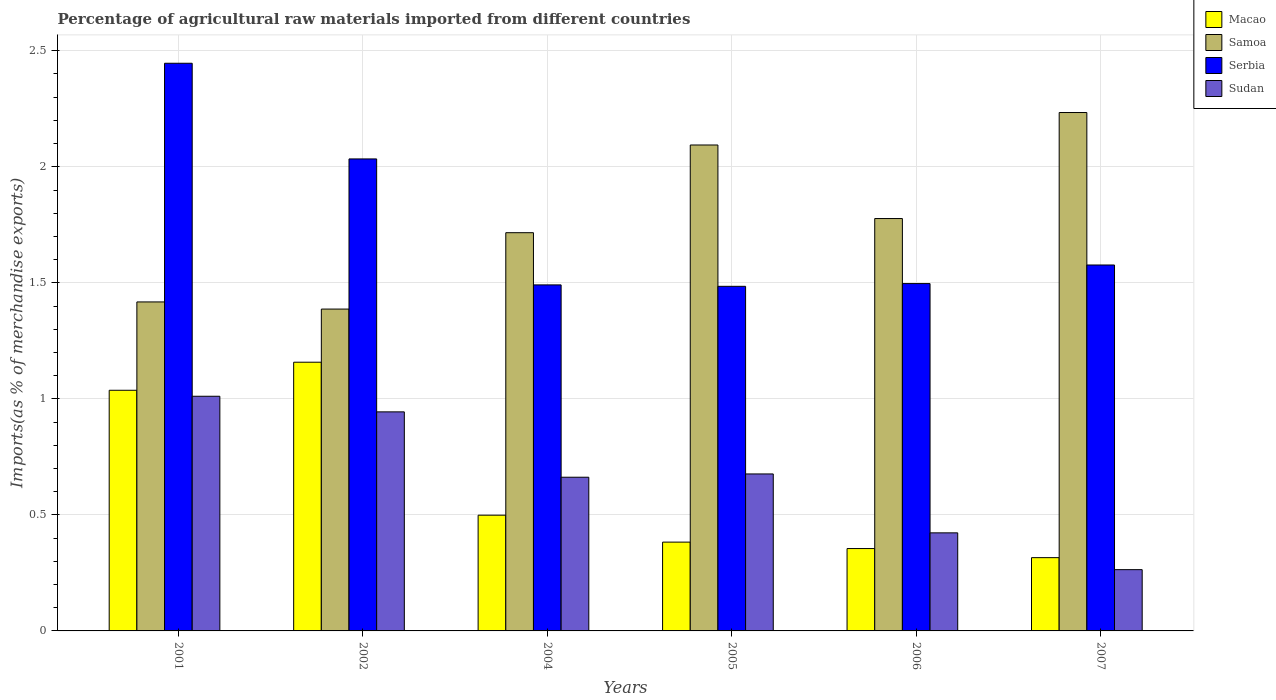How many different coloured bars are there?
Offer a very short reply. 4. Are the number of bars on each tick of the X-axis equal?
Provide a short and direct response. Yes. What is the label of the 6th group of bars from the left?
Provide a succinct answer. 2007. What is the percentage of imports to different countries in Macao in 2004?
Keep it short and to the point. 0.5. Across all years, what is the maximum percentage of imports to different countries in Sudan?
Your response must be concise. 1.01. Across all years, what is the minimum percentage of imports to different countries in Sudan?
Make the answer very short. 0.26. In which year was the percentage of imports to different countries in Serbia maximum?
Your answer should be very brief. 2001. What is the total percentage of imports to different countries in Samoa in the graph?
Offer a terse response. 10.63. What is the difference between the percentage of imports to different countries in Macao in 2004 and that in 2005?
Your answer should be compact. 0.12. What is the difference between the percentage of imports to different countries in Samoa in 2001 and the percentage of imports to different countries in Sudan in 2004?
Offer a very short reply. 0.76. What is the average percentage of imports to different countries in Macao per year?
Your response must be concise. 0.62. In the year 2005, what is the difference between the percentage of imports to different countries in Sudan and percentage of imports to different countries in Samoa?
Your response must be concise. -1.42. In how many years, is the percentage of imports to different countries in Serbia greater than 1.6 %?
Your response must be concise. 2. What is the ratio of the percentage of imports to different countries in Macao in 2006 to that in 2007?
Your answer should be very brief. 1.12. What is the difference between the highest and the second highest percentage of imports to different countries in Sudan?
Offer a terse response. 0.07. What is the difference between the highest and the lowest percentage of imports to different countries in Sudan?
Provide a short and direct response. 0.75. In how many years, is the percentage of imports to different countries in Macao greater than the average percentage of imports to different countries in Macao taken over all years?
Ensure brevity in your answer.  2. Is the sum of the percentage of imports to different countries in Samoa in 2004 and 2005 greater than the maximum percentage of imports to different countries in Serbia across all years?
Provide a succinct answer. Yes. What does the 3rd bar from the left in 2001 represents?
Keep it short and to the point. Serbia. What does the 4th bar from the right in 2002 represents?
Make the answer very short. Macao. How many bars are there?
Provide a succinct answer. 24. What is the difference between two consecutive major ticks on the Y-axis?
Provide a short and direct response. 0.5. Are the values on the major ticks of Y-axis written in scientific E-notation?
Give a very brief answer. No. What is the title of the graph?
Your response must be concise. Percentage of agricultural raw materials imported from different countries. Does "Rwanda" appear as one of the legend labels in the graph?
Your answer should be compact. No. What is the label or title of the X-axis?
Offer a very short reply. Years. What is the label or title of the Y-axis?
Offer a terse response. Imports(as % of merchandise exports). What is the Imports(as % of merchandise exports) of Macao in 2001?
Your answer should be very brief. 1.04. What is the Imports(as % of merchandise exports) of Samoa in 2001?
Provide a short and direct response. 1.42. What is the Imports(as % of merchandise exports) of Serbia in 2001?
Give a very brief answer. 2.45. What is the Imports(as % of merchandise exports) of Sudan in 2001?
Ensure brevity in your answer.  1.01. What is the Imports(as % of merchandise exports) in Macao in 2002?
Your answer should be compact. 1.16. What is the Imports(as % of merchandise exports) in Samoa in 2002?
Give a very brief answer. 1.39. What is the Imports(as % of merchandise exports) of Serbia in 2002?
Provide a short and direct response. 2.03. What is the Imports(as % of merchandise exports) in Sudan in 2002?
Your response must be concise. 0.94. What is the Imports(as % of merchandise exports) in Macao in 2004?
Offer a terse response. 0.5. What is the Imports(as % of merchandise exports) in Samoa in 2004?
Provide a short and direct response. 1.72. What is the Imports(as % of merchandise exports) in Serbia in 2004?
Your answer should be very brief. 1.49. What is the Imports(as % of merchandise exports) in Sudan in 2004?
Give a very brief answer. 0.66. What is the Imports(as % of merchandise exports) of Macao in 2005?
Your answer should be compact. 0.38. What is the Imports(as % of merchandise exports) of Samoa in 2005?
Your response must be concise. 2.09. What is the Imports(as % of merchandise exports) in Serbia in 2005?
Your response must be concise. 1.48. What is the Imports(as % of merchandise exports) of Sudan in 2005?
Provide a succinct answer. 0.68. What is the Imports(as % of merchandise exports) in Macao in 2006?
Your response must be concise. 0.35. What is the Imports(as % of merchandise exports) of Samoa in 2006?
Your answer should be very brief. 1.78. What is the Imports(as % of merchandise exports) in Serbia in 2006?
Keep it short and to the point. 1.5. What is the Imports(as % of merchandise exports) of Sudan in 2006?
Offer a very short reply. 0.42. What is the Imports(as % of merchandise exports) of Macao in 2007?
Provide a short and direct response. 0.32. What is the Imports(as % of merchandise exports) of Samoa in 2007?
Provide a short and direct response. 2.23. What is the Imports(as % of merchandise exports) of Serbia in 2007?
Your answer should be very brief. 1.58. What is the Imports(as % of merchandise exports) in Sudan in 2007?
Keep it short and to the point. 0.26. Across all years, what is the maximum Imports(as % of merchandise exports) of Macao?
Your response must be concise. 1.16. Across all years, what is the maximum Imports(as % of merchandise exports) of Samoa?
Offer a terse response. 2.23. Across all years, what is the maximum Imports(as % of merchandise exports) of Serbia?
Make the answer very short. 2.45. Across all years, what is the maximum Imports(as % of merchandise exports) of Sudan?
Make the answer very short. 1.01. Across all years, what is the minimum Imports(as % of merchandise exports) of Macao?
Your answer should be compact. 0.32. Across all years, what is the minimum Imports(as % of merchandise exports) in Samoa?
Your answer should be compact. 1.39. Across all years, what is the minimum Imports(as % of merchandise exports) of Serbia?
Ensure brevity in your answer.  1.48. Across all years, what is the minimum Imports(as % of merchandise exports) in Sudan?
Provide a short and direct response. 0.26. What is the total Imports(as % of merchandise exports) in Macao in the graph?
Make the answer very short. 3.75. What is the total Imports(as % of merchandise exports) in Samoa in the graph?
Provide a short and direct response. 10.63. What is the total Imports(as % of merchandise exports) of Serbia in the graph?
Ensure brevity in your answer.  10.53. What is the total Imports(as % of merchandise exports) of Sudan in the graph?
Give a very brief answer. 3.98. What is the difference between the Imports(as % of merchandise exports) in Macao in 2001 and that in 2002?
Provide a short and direct response. -0.12. What is the difference between the Imports(as % of merchandise exports) of Samoa in 2001 and that in 2002?
Provide a succinct answer. 0.03. What is the difference between the Imports(as % of merchandise exports) in Serbia in 2001 and that in 2002?
Ensure brevity in your answer.  0.41. What is the difference between the Imports(as % of merchandise exports) of Sudan in 2001 and that in 2002?
Provide a short and direct response. 0.07. What is the difference between the Imports(as % of merchandise exports) of Macao in 2001 and that in 2004?
Your answer should be very brief. 0.54. What is the difference between the Imports(as % of merchandise exports) in Samoa in 2001 and that in 2004?
Ensure brevity in your answer.  -0.3. What is the difference between the Imports(as % of merchandise exports) in Serbia in 2001 and that in 2004?
Provide a succinct answer. 0.96. What is the difference between the Imports(as % of merchandise exports) of Sudan in 2001 and that in 2004?
Ensure brevity in your answer.  0.35. What is the difference between the Imports(as % of merchandise exports) in Macao in 2001 and that in 2005?
Offer a terse response. 0.65. What is the difference between the Imports(as % of merchandise exports) of Samoa in 2001 and that in 2005?
Provide a short and direct response. -0.68. What is the difference between the Imports(as % of merchandise exports) of Serbia in 2001 and that in 2005?
Provide a succinct answer. 0.96. What is the difference between the Imports(as % of merchandise exports) of Sudan in 2001 and that in 2005?
Your response must be concise. 0.33. What is the difference between the Imports(as % of merchandise exports) in Macao in 2001 and that in 2006?
Your answer should be very brief. 0.68. What is the difference between the Imports(as % of merchandise exports) in Samoa in 2001 and that in 2006?
Your answer should be very brief. -0.36. What is the difference between the Imports(as % of merchandise exports) of Serbia in 2001 and that in 2006?
Offer a very short reply. 0.95. What is the difference between the Imports(as % of merchandise exports) of Sudan in 2001 and that in 2006?
Make the answer very short. 0.59. What is the difference between the Imports(as % of merchandise exports) in Macao in 2001 and that in 2007?
Keep it short and to the point. 0.72. What is the difference between the Imports(as % of merchandise exports) in Samoa in 2001 and that in 2007?
Provide a succinct answer. -0.82. What is the difference between the Imports(as % of merchandise exports) of Serbia in 2001 and that in 2007?
Provide a short and direct response. 0.87. What is the difference between the Imports(as % of merchandise exports) of Sudan in 2001 and that in 2007?
Your answer should be very brief. 0.75. What is the difference between the Imports(as % of merchandise exports) of Macao in 2002 and that in 2004?
Offer a terse response. 0.66. What is the difference between the Imports(as % of merchandise exports) of Samoa in 2002 and that in 2004?
Your answer should be compact. -0.33. What is the difference between the Imports(as % of merchandise exports) of Serbia in 2002 and that in 2004?
Provide a short and direct response. 0.54. What is the difference between the Imports(as % of merchandise exports) in Sudan in 2002 and that in 2004?
Offer a very short reply. 0.28. What is the difference between the Imports(as % of merchandise exports) in Macao in 2002 and that in 2005?
Ensure brevity in your answer.  0.78. What is the difference between the Imports(as % of merchandise exports) of Samoa in 2002 and that in 2005?
Make the answer very short. -0.71. What is the difference between the Imports(as % of merchandise exports) in Serbia in 2002 and that in 2005?
Keep it short and to the point. 0.55. What is the difference between the Imports(as % of merchandise exports) of Sudan in 2002 and that in 2005?
Your answer should be compact. 0.27. What is the difference between the Imports(as % of merchandise exports) in Macao in 2002 and that in 2006?
Give a very brief answer. 0.8. What is the difference between the Imports(as % of merchandise exports) in Samoa in 2002 and that in 2006?
Your answer should be very brief. -0.39. What is the difference between the Imports(as % of merchandise exports) of Serbia in 2002 and that in 2006?
Give a very brief answer. 0.54. What is the difference between the Imports(as % of merchandise exports) in Sudan in 2002 and that in 2006?
Offer a terse response. 0.52. What is the difference between the Imports(as % of merchandise exports) in Macao in 2002 and that in 2007?
Your response must be concise. 0.84. What is the difference between the Imports(as % of merchandise exports) of Samoa in 2002 and that in 2007?
Offer a very short reply. -0.85. What is the difference between the Imports(as % of merchandise exports) in Serbia in 2002 and that in 2007?
Your response must be concise. 0.46. What is the difference between the Imports(as % of merchandise exports) in Sudan in 2002 and that in 2007?
Make the answer very short. 0.68. What is the difference between the Imports(as % of merchandise exports) of Macao in 2004 and that in 2005?
Ensure brevity in your answer.  0.12. What is the difference between the Imports(as % of merchandise exports) in Samoa in 2004 and that in 2005?
Offer a very short reply. -0.38. What is the difference between the Imports(as % of merchandise exports) of Serbia in 2004 and that in 2005?
Your response must be concise. 0.01. What is the difference between the Imports(as % of merchandise exports) in Sudan in 2004 and that in 2005?
Provide a short and direct response. -0.01. What is the difference between the Imports(as % of merchandise exports) of Macao in 2004 and that in 2006?
Keep it short and to the point. 0.14. What is the difference between the Imports(as % of merchandise exports) of Samoa in 2004 and that in 2006?
Offer a terse response. -0.06. What is the difference between the Imports(as % of merchandise exports) in Serbia in 2004 and that in 2006?
Offer a very short reply. -0.01. What is the difference between the Imports(as % of merchandise exports) in Sudan in 2004 and that in 2006?
Offer a terse response. 0.24. What is the difference between the Imports(as % of merchandise exports) of Macao in 2004 and that in 2007?
Provide a succinct answer. 0.18. What is the difference between the Imports(as % of merchandise exports) in Samoa in 2004 and that in 2007?
Keep it short and to the point. -0.52. What is the difference between the Imports(as % of merchandise exports) in Serbia in 2004 and that in 2007?
Give a very brief answer. -0.09. What is the difference between the Imports(as % of merchandise exports) in Sudan in 2004 and that in 2007?
Your answer should be very brief. 0.4. What is the difference between the Imports(as % of merchandise exports) of Macao in 2005 and that in 2006?
Your answer should be compact. 0.03. What is the difference between the Imports(as % of merchandise exports) in Samoa in 2005 and that in 2006?
Give a very brief answer. 0.32. What is the difference between the Imports(as % of merchandise exports) in Serbia in 2005 and that in 2006?
Make the answer very short. -0.01. What is the difference between the Imports(as % of merchandise exports) of Sudan in 2005 and that in 2006?
Give a very brief answer. 0.25. What is the difference between the Imports(as % of merchandise exports) in Macao in 2005 and that in 2007?
Give a very brief answer. 0.07. What is the difference between the Imports(as % of merchandise exports) in Samoa in 2005 and that in 2007?
Your response must be concise. -0.14. What is the difference between the Imports(as % of merchandise exports) in Serbia in 2005 and that in 2007?
Give a very brief answer. -0.09. What is the difference between the Imports(as % of merchandise exports) in Sudan in 2005 and that in 2007?
Keep it short and to the point. 0.41. What is the difference between the Imports(as % of merchandise exports) in Macao in 2006 and that in 2007?
Give a very brief answer. 0.04. What is the difference between the Imports(as % of merchandise exports) in Samoa in 2006 and that in 2007?
Ensure brevity in your answer.  -0.46. What is the difference between the Imports(as % of merchandise exports) in Serbia in 2006 and that in 2007?
Your answer should be very brief. -0.08. What is the difference between the Imports(as % of merchandise exports) in Sudan in 2006 and that in 2007?
Your answer should be compact. 0.16. What is the difference between the Imports(as % of merchandise exports) in Macao in 2001 and the Imports(as % of merchandise exports) in Samoa in 2002?
Make the answer very short. -0.35. What is the difference between the Imports(as % of merchandise exports) of Macao in 2001 and the Imports(as % of merchandise exports) of Serbia in 2002?
Provide a succinct answer. -1. What is the difference between the Imports(as % of merchandise exports) of Macao in 2001 and the Imports(as % of merchandise exports) of Sudan in 2002?
Provide a succinct answer. 0.09. What is the difference between the Imports(as % of merchandise exports) of Samoa in 2001 and the Imports(as % of merchandise exports) of Serbia in 2002?
Provide a succinct answer. -0.62. What is the difference between the Imports(as % of merchandise exports) in Samoa in 2001 and the Imports(as % of merchandise exports) in Sudan in 2002?
Your answer should be compact. 0.47. What is the difference between the Imports(as % of merchandise exports) of Serbia in 2001 and the Imports(as % of merchandise exports) of Sudan in 2002?
Offer a very short reply. 1.5. What is the difference between the Imports(as % of merchandise exports) in Macao in 2001 and the Imports(as % of merchandise exports) in Samoa in 2004?
Give a very brief answer. -0.68. What is the difference between the Imports(as % of merchandise exports) of Macao in 2001 and the Imports(as % of merchandise exports) of Serbia in 2004?
Your answer should be compact. -0.45. What is the difference between the Imports(as % of merchandise exports) of Macao in 2001 and the Imports(as % of merchandise exports) of Sudan in 2004?
Your response must be concise. 0.37. What is the difference between the Imports(as % of merchandise exports) of Samoa in 2001 and the Imports(as % of merchandise exports) of Serbia in 2004?
Your answer should be compact. -0.07. What is the difference between the Imports(as % of merchandise exports) of Samoa in 2001 and the Imports(as % of merchandise exports) of Sudan in 2004?
Ensure brevity in your answer.  0.76. What is the difference between the Imports(as % of merchandise exports) in Serbia in 2001 and the Imports(as % of merchandise exports) in Sudan in 2004?
Your response must be concise. 1.78. What is the difference between the Imports(as % of merchandise exports) of Macao in 2001 and the Imports(as % of merchandise exports) of Samoa in 2005?
Offer a terse response. -1.06. What is the difference between the Imports(as % of merchandise exports) in Macao in 2001 and the Imports(as % of merchandise exports) in Serbia in 2005?
Make the answer very short. -0.45. What is the difference between the Imports(as % of merchandise exports) in Macao in 2001 and the Imports(as % of merchandise exports) in Sudan in 2005?
Offer a terse response. 0.36. What is the difference between the Imports(as % of merchandise exports) in Samoa in 2001 and the Imports(as % of merchandise exports) in Serbia in 2005?
Make the answer very short. -0.07. What is the difference between the Imports(as % of merchandise exports) of Samoa in 2001 and the Imports(as % of merchandise exports) of Sudan in 2005?
Your answer should be very brief. 0.74. What is the difference between the Imports(as % of merchandise exports) of Serbia in 2001 and the Imports(as % of merchandise exports) of Sudan in 2005?
Your answer should be compact. 1.77. What is the difference between the Imports(as % of merchandise exports) in Macao in 2001 and the Imports(as % of merchandise exports) in Samoa in 2006?
Give a very brief answer. -0.74. What is the difference between the Imports(as % of merchandise exports) in Macao in 2001 and the Imports(as % of merchandise exports) in Serbia in 2006?
Offer a very short reply. -0.46. What is the difference between the Imports(as % of merchandise exports) in Macao in 2001 and the Imports(as % of merchandise exports) in Sudan in 2006?
Your answer should be compact. 0.61. What is the difference between the Imports(as % of merchandise exports) in Samoa in 2001 and the Imports(as % of merchandise exports) in Serbia in 2006?
Your response must be concise. -0.08. What is the difference between the Imports(as % of merchandise exports) in Samoa in 2001 and the Imports(as % of merchandise exports) in Sudan in 2006?
Your answer should be compact. 1. What is the difference between the Imports(as % of merchandise exports) in Serbia in 2001 and the Imports(as % of merchandise exports) in Sudan in 2006?
Your answer should be compact. 2.02. What is the difference between the Imports(as % of merchandise exports) in Macao in 2001 and the Imports(as % of merchandise exports) in Samoa in 2007?
Provide a succinct answer. -1.2. What is the difference between the Imports(as % of merchandise exports) in Macao in 2001 and the Imports(as % of merchandise exports) in Serbia in 2007?
Give a very brief answer. -0.54. What is the difference between the Imports(as % of merchandise exports) of Macao in 2001 and the Imports(as % of merchandise exports) of Sudan in 2007?
Offer a terse response. 0.77. What is the difference between the Imports(as % of merchandise exports) of Samoa in 2001 and the Imports(as % of merchandise exports) of Serbia in 2007?
Ensure brevity in your answer.  -0.16. What is the difference between the Imports(as % of merchandise exports) in Samoa in 2001 and the Imports(as % of merchandise exports) in Sudan in 2007?
Ensure brevity in your answer.  1.15. What is the difference between the Imports(as % of merchandise exports) in Serbia in 2001 and the Imports(as % of merchandise exports) in Sudan in 2007?
Offer a terse response. 2.18. What is the difference between the Imports(as % of merchandise exports) in Macao in 2002 and the Imports(as % of merchandise exports) in Samoa in 2004?
Provide a short and direct response. -0.56. What is the difference between the Imports(as % of merchandise exports) in Macao in 2002 and the Imports(as % of merchandise exports) in Serbia in 2004?
Provide a succinct answer. -0.33. What is the difference between the Imports(as % of merchandise exports) of Macao in 2002 and the Imports(as % of merchandise exports) of Sudan in 2004?
Offer a terse response. 0.5. What is the difference between the Imports(as % of merchandise exports) in Samoa in 2002 and the Imports(as % of merchandise exports) in Serbia in 2004?
Your response must be concise. -0.1. What is the difference between the Imports(as % of merchandise exports) in Samoa in 2002 and the Imports(as % of merchandise exports) in Sudan in 2004?
Your response must be concise. 0.72. What is the difference between the Imports(as % of merchandise exports) of Serbia in 2002 and the Imports(as % of merchandise exports) of Sudan in 2004?
Your response must be concise. 1.37. What is the difference between the Imports(as % of merchandise exports) in Macao in 2002 and the Imports(as % of merchandise exports) in Samoa in 2005?
Provide a short and direct response. -0.94. What is the difference between the Imports(as % of merchandise exports) in Macao in 2002 and the Imports(as % of merchandise exports) in Serbia in 2005?
Offer a terse response. -0.33. What is the difference between the Imports(as % of merchandise exports) in Macao in 2002 and the Imports(as % of merchandise exports) in Sudan in 2005?
Give a very brief answer. 0.48. What is the difference between the Imports(as % of merchandise exports) of Samoa in 2002 and the Imports(as % of merchandise exports) of Serbia in 2005?
Keep it short and to the point. -0.1. What is the difference between the Imports(as % of merchandise exports) in Samoa in 2002 and the Imports(as % of merchandise exports) in Sudan in 2005?
Your answer should be compact. 0.71. What is the difference between the Imports(as % of merchandise exports) of Serbia in 2002 and the Imports(as % of merchandise exports) of Sudan in 2005?
Offer a very short reply. 1.36. What is the difference between the Imports(as % of merchandise exports) in Macao in 2002 and the Imports(as % of merchandise exports) in Samoa in 2006?
Offer a terse response. -0.62. What is the difference between the Imports(as % of merchandise exports) in Macao in 2002 and the Imports(as % of merchandise exports) in Serbia in 2006?
Your answer should be compact. -0.34. What is the difference between the Imports(as % of merchandise exports) of Macao in 2002 and the Imports(as % of merchandise exports) of Sudan in 2006?
Offer a very short reply. 0.74. What is the difference between the Imports(as % of merchandise exports) in Samoa in 2002 and the Imports(as % of merchandise exports) in Serbia in 2006?
Keep it short and to the point. -0.11. What is the difference between the Imports(as % of merchandise exports) in Samoa in 2002 and the Imports(as % of merchandise exports) in Sudan in 2006?
Offer a very short reply. 0.96. What is the difference between the Imports(as % of merchandise exports) in Serbia in 2002 and the Imports(as % of merchandise exports) in Sudan in 2006?
Your response must be concise. 1.61. What is the difference between the Imports(as % of merchandise exports) of Macao in 2002 and the Imports(as % of merchandise exports) of Samoa in 2007?
Give a very brief answer. -1.08. What is the difference between the Imports(as % of merchandise exports) of Macao in 2002 and the Imports(as % of merchandise exports) of Serbia in 2007?
Give a very brief answer. -0.42. What is the difference between the Imports(as % of merchandise exports) of Macao in 2002 and the Imports(as % of merchandise exports) of Sudan in 2007?
Make the answer very short. 0.89. What is the difference between the Imports(as % of merchandise exports) in Samoa in 2002 and the Imports(as % of merchandise exports) in Serbia in 2007?
Your response must be concise. -0.19. What is the difference between the Imports(as % of merchandise exports) of Samoa in 2002 and the Imports(as % of merchandise exports) of Sudan in 2007?
Ensure brevity in your answer.  1.12. What is the difference between the Imports(as % of merchandise exports) of Serbia in 2002 and the Imports(as % of merchandise exports) of Sudan in 2007?
Your answer should be very brief. 1.77. What is the difference between the Imports(as % of merchandise exports) in Macao in 2004 and the Imports(as % of merchandise exports) in Samoa in 2005?
Your answer should be very brief. -1.6. What is the difference between the Imports(as % of merchandise exports) in Macao in 2004 and the Imports(as % of merchandise exports) in Serbia in 2005?
Provide a succinct answer. -0.99. What is the difference between the Imports(as % of merchandise exports) in Macao in 2004 and the Imports(as % of merchandise exports) in Sudan in 2005?
Offer a terse response. -0.18. What is the difference between the Imports(as % of merchandise exports) in Samoa in 2004 and the Imports(as % of merchandise exports) in Serbia in 2005?
Your answer should be very brief. 0.23. What is the difference between the Imports(as % of merchandise exports) of Samoa in 2004 and the Imports(as % of merchandise exports) of Sudan in 2005?
Give a very brief answer. 1.04. What is the difference between the Imports(as % of merchandise exports) of Serbia in 2004 and the Imports(as % of merchandise exports) of Sudan in 2005?
Offer a terse response. 0.81. What is the difference between the Imports(as % of merchandise exports) of Macao in 2004 and the Imports(as % of merchandise exports) of Samoa in 2006?
Offer a terse response. -1.28. What is the difference between the Imports(as % of merchandise exports) in Macao in 2004 and the Imports(as % of merchandise exports) in Serbia in 2006?
Offer a terse response. -1. What is the difference between the Imports(as % of merchandise exports) in Macao in 2004 and the Imports(as % of merchandise exports) in Sudan in 2006?
Offer a very short reply. 0.08. What is the difference between the Imports(as % of merchandise exports) in Samoa in 2004 and the Imports(as % of merchandise exports) in Serbia in 2006?
Offer a very short reply. 0.22. What is the difference between the Imports(as % of merchandise exports) in Samoa in 2004 and the Imports(as % of merchandise exports) in Sudan in 2006?
Offer a terse response. 1.29. What is the difference between the Imports(as % of merchandise exports) in Serbia in 2004 and the Imports(as % of merchandise exports) in Sudan in 2006?
Keep it short and to the point. 1.07. What is the difference between the Imports(as % of merchandise exports) of Macao in 2004 and the Imports(as % of merchandise exports) of Samoa in 2007?
Give a very brief answer. -1.74. What is the difference between the Imports(as % of merchandise exports) of Macao in 2004 and the Imports(as % of merchandise exports) of Serbia in 2007?
Your answer should be compact. -1.08. What is the difference between the Imports(as % of merchandise exports) in Macao in 2004 and the Imports(as % of merchandise exports) in Sudan in 2007?
Offer a very short reply. 0.23. What is the difference between the Imports(as % of merchandise exports) in Samoa in 2004 and the Imports(as % of merchandise exports) in Serbia in 2007?
Your answer should be compact. 0.14. What is the difference between the Imports(as % of merchandise exports) of Samoa in 2004 and the Imports(as % of merchandise exports) of Sudan in 2007?
Make the answer very short. 1.45. What is the difference between the Imports(as % of merchandise exports) of Serbia in 2004 and the Imports(as % of merchandise exports) of Sudan in 2007?
Offer a very short reply. 1.23. What is the difference between the Imports(as % of merchandise exports) in Macao in 2005 and the Imports(as % of merchandise exports) in Samoa in 2006?
Your answer should be very brief. -1.39. What is the difference between the Imports(as % of merchandise exports) in Macao in 2005 and the Imports(as % of merchandise exports) in Serbia in 2006?
Provide a short and direct response. -1.11. What is the difference between the Imports(as % of merchandise exports) in Macao in 2005 and the Imports(as % of merchandise exports) in Sudan in 2006?
Offer a terse response. -0.04. What is the difference between the Imports(as % of merchandise exports) of Samoa in 2005 and the Imports(as % of merchandise exports) of Serbia in 2006?
Provide a short and direct response. 0.6. What is the difference between the Imports(as % of merchandise exports) in Samoa in 2005 and the Imports(as % of merchandise exports) in Sudan in 2006?
Offer a terse response. 1.67. What is the difference between the Imports(as % of merchandise exports) in Serbia in 2005 and the Imports(as % of merchandise exports) in Sudan in 2006?
Offer a terse response. 1.06. What is the difference between the Imports(as % of merchandise exports) of Macao in 2005 and the Imports(as % of merchandise exports) of Samoa in 2007?
Make the answer very short. -1.85. What is the difference between the Imports(as % of merchandise exports) of Macao in 2005 and the Imports(as % of merchandise exports) of Serbia in 2007?
Your response must be concise. -1.19. What is the difference between the Imports(as % of merchandise exports) in Macao in 2005 and the Imports(as % of merchandise exports) in Sudan in 2007?
Make the answer very short. 0.12. What is the difference between the Imports(as % of merchandise exports) of Samoa in 2005 and the Imports(as % of merchandise exports) of Serbia in 2007?
Your answer should be very brief. 0.52. What is the difference between the Imports(as % of merchandise exports) in Samoa in 2005 and the Imports(as % of merchandise exports) in Sudan in 2007?
Provide a short and direct response. 1.83. What is the difference between the Imports(as % of merchandise exports) of Serbia in 2005 and the Imports(as % of merchandise exports) of Sudan in 2007?
Your response must be concise. 1.22. What is the difference between the Imports(as % of merchandise exports) in Macao in 2006 and the Imports(as % of merchandise exports) in Samoa in 2007?
Your response must be concise. -1.88. What is the difference between the Imports(as % of merchandise exports) of Macao in 2006 and the Imports(as % of merchandise exports) of Serbia in 2007?
Your answer should be very brief. -1.22. What is the difference between the Imports(as % of merchandise exports) in Macao in 2006 and the Imports(as % of merchandise exports) in Sudan in 2007?
Your answer should be very brief. 0.09. What is the difference between the Imports(as % of merchandise exports) in Samoa in 2006 and the Imports(as % of merchandise exports) in Serbia in 2007?
Provide a succinct answer. 0.2. What is the difference between the Imports(as % of merchandise exports) of Samoa in 2006 and the Imports(as % of merchandise exports) of Sudan in 2007?
Your response must be concise. 1.51. What is the difference between the Imports(as % of merchandise exports) of Serbia in 2006 and the Imports(as % of merchandise exports) of Sudan in 2007?
Ensure brevity in your answer.  1.23. What is the average Imports(as % of merchandise exports) of Macao per year?
Your response must be concise. 0.62. What is the average Imports(as % of merchandise exports) in Samoa per year?
Your response must be concise. 1.77. What is the average Imports(as % of merchandise exports) of Serbia per year?
Your answer should be very brief. 1.75. What is the average Imports(as % of merchandise exports) of Sudan per year?
Keep it short and to the point. 0.66. In the year 2001, what is the difference between the Imports(as % of merchandise exports) of Macao and Imports(as % of merchandise exports) of Samoa?
Your answer should be compact. -0.38. In the year 2001, what is the difference between the Imports(as % of merchandise exports) in Macao and Imports(as % of merchandise exports) in Serbia?
Keep it short and to the point. -1.41. In the year 2001, what is the difference between the Imports(as % of merchandise exports) in Macao and Imports(as % of merchandise exports) in Sudan?
Offer a terse response. 0.03. In the year 2001, what is the difference between the Imports(as % of merchandise exports) of Samoa and Imports(as % of merchandise exports) of Serbia?
Your answer should be compact. -1.03. In the year 2001, what is the difference between the Imports(as % of merchandise exports) of Samoa and Imports(as % of merchandise exports) of Sudan?
Ensure brevity in your answer.  0.41. In the year 2001, what is the difference between the Imports(as % of merchandise exports) in Serbia and Imports(as % of merchandise exports) in Sudan?
Offer a terse response. 1.44. In the year 2002, what is the difference between the Imports(as % of merchandise exports) of Macao and Imports(as % of merchandise exports) of Samoa?
Provide a short and direct response. -0.23. In the year 2002, what is the difference between the Imports(as % of merchandise exports) in Macao and Imports(as % of merchandise exports) in Serbia?
Give a very brief answer. -0.88. In the year 2002, what is the difference between the Imports(as % of merchandise exports) of Macao and Imports(as % of merchandise exports) of Sudan?
Your response must be concise. 0.21. In the year 2002, what is the difference between the Imports(as % of merchandise exports) in Samoa and Imports(as % of merchandise exports) in Serbia?
Offer a very short reply. -0.65. In the year 2002, what is the difference between the Imports(as % of merchandise exports) in Samoa and Imports(as % of merchandise exports) in Sudan?
Your answer should be very brief. 0.44. In the year 2002, what is the difference between the Imports(as % of merchandise exports) in Serbia and Imports(as % of merchandise exports) in Sudan?
Provide a succinct answer. 1.09. In the year 2004, what is the difference between the Imports(as % of merchandise exports) of Macao and Imports(as % of merchandise exports) of Samoa?
Offer a very short reply. -1.22. In the year 2004, what is the difference between the Imports(as % of merchandise exports) in Macao and Imports(as % of merchandise exports) in Serbia?
Your answer should be very brief. -0.99. In the year 2004, what is the difference between the Imports(as % of merchandise exports) in Macao and Imports(as % of merchandise exports) in Sudan?
Keep it short and to the point. -0.16. In the year 2004, what is the difference between the Imports(as % of merchandise exports) in Samoa and Imports(as % of merchandise exports) in Serbia?
Give a very brief answer. 0.22. In the year 2004, what is the difference between the Imports(as % of merchandise exports) of Samoa and Imports(as % of merchandise exports) of Sudan?
Your answer should be compact. 1.05. In the year 2004, what is the difference between the Imports(as % of merchandise exports) in Serbia and Imports(as % of merchandise exports) in Sudan?
Offer a very short reply. 0.83. In the year 2005, what is the difference between the Imports(as % of merchandise exports) in Macao and Imports(as % of merchandise exports) in Samoa?
Your response must be concise. -1.71. In the year 2005, what is the difference between the Imports(as % of merchandise exports) in Macao and Imports(as % of merchandise exports) in Serbia?
Provide a short and direct response. -1.1. In the year 2005, what is the difference between the Imports(as % of merchandise exports) in Macao and Imports(as % of merchandise exports) in Sudan?
Your answer should be compact. -0.29. In the year 2005, what is the difference between the Imports(as % of merchandise exports) of Samoa and Imports(as % of merchandise exports) of Serbia?
Your response must be concise. 0.61. In the year 2005, what is the difference between the Imports(as % of merchandise exports) in Samoa and Imports(as % of merchandise exports) in Sudan?
Ensure brevity in your answer.  1.42. In the year 2005, what is the difference between the Imports(as % of merchandise exports) in Serbia and Imports(as % of merchandise exports) in Sudan?
Your response must be concise. 0.81. In the year 2006, what is the difference between the Imports(as % of merchandise exports) of Macao and Imports(as % of merchandise exports) of Samoa?
Provide a short and direct response. -1.42. In the year 2006, what is the difference between the Imports(as % of merchandise exports) in Macao and Imports(as % of merchandise exports) in Serbia?
Provide a succinct answer. -1.14. In the year 2006, what is the difference between the Imports(as % of merchandise exports) of Macao and Imports(as % of merchandise exports) of Sudan?
Your answer should be very brief. -0.07. In the year 2006, what is the difference between the Imports(as % of merchandise exports) in Samoa and Imports(as % of merchandise exports) in Serbia?
Keep it short and to the point. 0.28. In the year 2006, what is the difference between the Imports(as % of merchandise exports) in Samoa and Imports(as % of merchandise exports) in Sudan?
Offer a very short reply. 1.35. In the year 2006, what is the difference between the Imports(as % of merchandise exports) in Serbia and Imports(as % of merchandise exports) in Sudan?
Make the answer very short. 1.07. In the year 2007, what is the difference between the Imports(as % of merchandise exports) in Macao and Imports(as % of merchandise exports) in Samoa?
Ensure brevity in your answer.  -1.92. In the year 2007, what is the difference between the Imports(as % of merchandise exports) of Macao and Imports(as % of merchandise exports) of Serbia?
Ensure brevity in your answer.  -1.26. In the year 2007, what is the difference between the Imports(as % of merchandise exports) of Macao and Imports(as % of merchandise exports) of Sudan?
Your answer should be very brief. 0.05. In the year 2007, what is the difference between the Imports(as % of merchandise exports) of Samoa and Imports(as % of merchandise exports) of Serbia?
Provide a succinct answer. 0.66. In the year 2007, what is the difference between the Imports(as % of merchandise exports) in Samoa and Imports(as % of merchandise exports) in Sudan?
Your answer should be very brief. 1.97. In the year 2007, what is the difference between the Imports(as % of merchandise exports) in Serbia and Imports(as % of merchandise exports) in Sudan?
Provide a short and direct response. 1.31. What is the ratio of the Imports(as % of merchandise exports) in Macao in 2001 to that in 2002?
Your answer should be compact. 0.9. What is the ratio of the Imports(as % of merchandise exports) of Samoa in 2001 to that in 2002?
Your response must be concise. 1.02. What is the ratio of the Imports(as % of merchandise exports) in Serbia in 2001 to that in 2002?
Ensure brevity in your answer.  1.2. What is the ratio of the Imports(as % of merchandise exports) in Sudan in 2001 to that in 2002?
Give a very brief answer. 1.07. What is the ratio of the Imports(as % of merchandise exports) of Macao in 2001 to that in 2004?
Your answer should be compact. 2.08. What is the ratio of the Imports(as % of merchandise exports) of Samoa in 2001 to that in 2004?
Your answer should be compact. 0.83. What is the ratio of the Imports(as % of merchandise exports) of Serbia in 2001 to that in 2004?
Keep it short and to the point. 1.64. What is the ratio of the Imports(as % of merchandise exports) in Sudan in 2001 to that in 2004?
Offer a terse response. 1.53. What is the ratio of the Imports(as % of merchandise exports) in Macao in 2001 to that in 2005?
Make the answer very short. 2.71. What is the ratio of the Imports(as % of merchandise exports) in Samoa in 2001 to that in 2005?
Your answer should be very brief. 0.68. What is the ratio of the Imports(as % of merchandise exports) of Serbia in 2001 to that in 2005?
Offer a very short reply. 1.65. What is the ratio of the Imports(as % of merchandise exports) of Sudan in 2001 to that in 2005?
Provide a succinct answer. 1.49. What is the ratio of the Imports(as % of merchandise exports) of Macao in 2001 to that in 2006?
Ensure brevity in your answer.  2.92. What is the ratio of the Imports(as % of merchandise exports) in Samoa in 2001 to that in 2006?
Your response must be concise. 0.8. What is the ratio of the Imports(as % of merchandise exports) of Serbia in 2001 to that in 2006?
Offer a terse response. 1.63. What is the ratio of the Imports(as % of merchandise exports) of Sudan in 2001 to that in 2006?
Give a very brief answer. 2.39. What is the ratio of the Imports(as % of merchandise exports) in Macao in 2001 to that in 2007?
Your answer should be compact. 3.28. What is the ratio of the Imports(as % of merchandise exports) in Samoa in 2001 to that in 2007?
Offer a terse response. 0.63. What is the ratio of the Imports(as % of merchandise exports) in Serbia in 2001 to that in 2007?
Offer a terse response. 1.55. What is the ratio of the Imports(as % of merchandise exports) in Sudan in 2001 to that in 2007?
Your response must be concise. 3.83. What is the ratio of the Imports(as % of merchandise exports) in Macao in 2002 to that in 2004?
Provide a succinct answer. 2.32. What is the ratio of the Imports(as % of merchandise exports) of Samoa in 2002 to that in 2004?
Provide a short and direct response. 0.81. What is the ratio of the Imports(as % of merchandise exports) in Serbia in 2002 to that in 2004?
Your answer should be very brief. 1.36. What is the ratio of the Imports(as % of merchandise exports) of Sudan in 2002 to that in 2004?
Offer a terse response. 1.43. What is the ratio of the Imports(as % of merchandise exports) of Macao in 2002 to that in 2005?
Make the answer very short. 3.03. What is the ratio of the Imports(as % of merchandise exports) in Samoa in 2002 to that in 2005?
Offer a terse response. 0.66. What is the ratio of the Imports(as % of merchandise exports) in Serbia in 2002 to that in 2005?
Ensure brevity in your answer.  1.37. What is the ratio of the Imports(as % of merchandise exports) of Sudan in 2002 to that in 2005?
Your answer should be compact. 1.4. What is the ratio of the Imports(as % of merchandise exports) of Macao in 2002 to that in 2006?
Your answer should be very brief. 3.26. What is the ratio of the Imports(as % of merchandise exports) of Samoa in 2002 to that in 2006?
Your answer should be very brief. 0.78. What is the ratio of the Imports(as % of merchandise exports) of Serbia in 2002 to that in 2006?
Ensure brevity in your answer.  1.36. What is the ratio of the Imports(as % of merchandise exports) in Sudan in 2002 to that in 2006?
Keep it short and to the point. 2.23. What is the ratio of the Imports(as % of merchandise exports) of Macao in 2002 to that in 2007?
Your response must be concise. 3.67. What is the ratio of the Imports(as % of merchandise exports) in Samoa in 2002 to that in 2007?
Keep it short and to the point. 0.62. What is the ratio of the Imports(as % of merchandise exports) of Serbia in 2002 to that in 2007?
Your response must be concise. 1.29. What is the ratio of the Imports(as % of merchandise exports) in Sudan in 2002 to that in 2007?
Your response must be concise. 3.58. What is the ratio of the Imports(as % of merchandise exports) of Macao in 2004 to that in 2005?
Provide a succinct answer. 1.3. What is the ratio of the Imports(as % of merchandise exports) in Samoa in 2004 to that in 2005?
Your answer should be compact. 0.82. What is the ratio of the Imports(as % of merchandise exports) in Sudan in 2004 to that in 2005?
Make the answer very short. 0.98. What is the ratio of the Imports(as % of merchandise exports) in Macao in 2004 to that in 2006?
Ensure brevity in your answer.  1.41. What is the ratio of the Imports(as % of merchandise exports) in Samoa in 2004 to that in 2006?
Offer a very short reply. 0.97. What is the ratio of the Imports(as % of merchandise exports) in Sudan in 2004 to that in 2006?
Your answer should be very brief. 1.57. What is the ratio of the Imports(as % of merchandise exports) in Macao in 2004 to that in 2007?
Your answer should be very brief. 1.58. What is the ratio of the Imports(as % of merchandise exports) of Samoa in 2004 to that in 2007?
Keep it short and to the point. 0.77. What is the ratio of the Imports(as % of merchandise exports) in Serbia in 2004 to that in 2007?
Provide a succinct answer. 0.95. What is the ratio of the Imports(as % of merchandise exports) in Sudan in 2004 to that in 2007?
Give a very brief answer. 2.51. What is the ratio of the Imports(as % of merchandise exports) in Macao in 2005 to that in 2006?
Keep it short and to the point. 1.08. What is the ratio of the Imports(as % of merchandise exports) of Samoa in 2005 to that in 2006?
Offer a terse response. 1.18. What is the ratio of the Imports(as % of merchandise exports) of Serbia in 2005 to that in 2006?
Keep it short and to the point. 0.99. What is the ratio of the Imports(as % of merchandise exports) of Sudan in 2005 to that in 2006?
Provide a succinct answer. 1.6. What is the ratio of the Imports(as % of merchandise exports) in Macao in 2005 to that in 2007?
Your answer should be compact. 1.21. What is the ratio of the Imports(as % of merchandise exports) of Samoa in 2005 to that in 2007?
Ensure brevity in your answer.  0.94. What is the ratio of the Imports(as % of merchandise exports) of Serbia in 2005 to that in 2007?
Give a very brief answer. 0.94. What is the ratio of the Imports(as % of merchandise exports) in Sudan in 2005 to that in 2007?
Offer a very short reply. 2.56. What is the ratio of the Imports(as % of merchandise exports) of Macao in 2006 to that in 2007?
Give a very brief answer. 1.12. What is the ratio of the Imports(as % of merchandise exports) of Samoa in 2006 to that in 2007?
Make the answer very short. 0.8. What is the ratio of the Imports(as % of merchandise exports) of Serbia in 2006 to that in 2007?
Your answer should be very brief. 0.95. What is the ratio of the Imports(as % of merchandise exports) in Sudan in 2006 to that in 2007?
Keep it short and to the point. 1.6. What is the difference between the highest and the second highest Imports(as % of merchandise exports) in Macao?
Offer a terse response. 0.12. What is the difference between the highest and the second highest Imports(as % of merchandise exports) in Samoa?
Provide a short and direct response. 0.14. What is the difference between the highest and the second highest Imports(as % of merchandise exports) of Serbia?
Your answer should be compact. 0.41. What is the difference between the highest and the second highest Imports(as % of merchandise exports) in Sudan?
Offer a very short reply. 0.07. What is the difference between the highest and the lowest Imports(as % of merchandise exports) of Macao?
Your answer should be very brief. 0.84. What is the difference between the highest and the lowest Imports(as % of merchandise exports) of Samoa?
Offer a very short reply. 0.85. What is the difference between the highest and the lowest Imports(as % of merchandise exports) in Serbia?
Make the answer very short. 0.96. What is the difference between the highest and the lowest Imports(as % of merchandise exports) of Sudan?
Your answer should be compact. 0.75. 